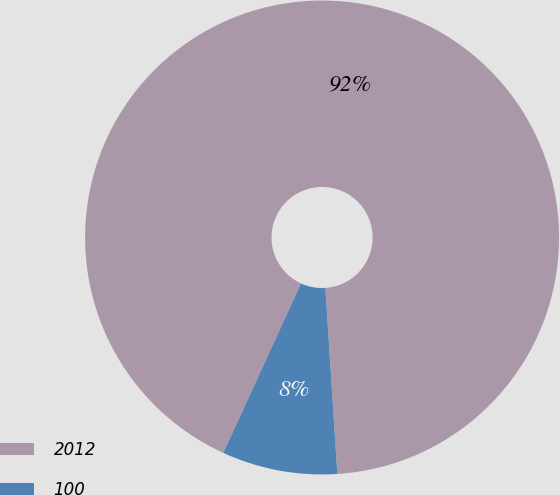Convert chart. <chart><loc_0><loc_0><loc_500><loc_500><pie_chart><fcel>2012<fcel>100<nl><fcel>92.13%<fcel>7.87%<nl></chart> 